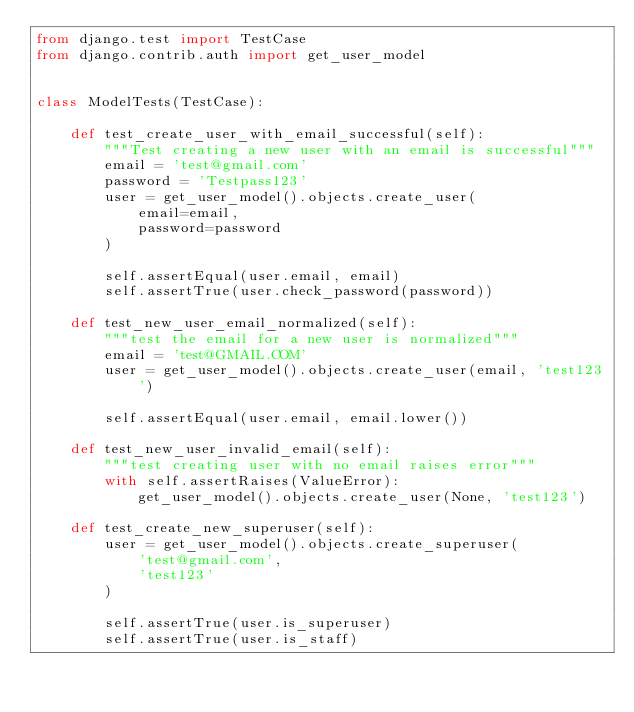Convert code to text. <code><loc_0><loc_0><loc_500><loc_500><_Python_>from django.test import TestCase
from django.contrib.auth import get_user_model


class ModelTests(TestCase):

    def test_create_user_with_email_successful(self):
        """Test creating a new user with an email is successful"""
        email = 'test@gmail.com'
        password = 'Testpass123'
        user = get_user_model().objects.create_user(
            email=email,
            password=password
        )

        self.assertEqual(user.email, email)
        self.assertTrue(user.check_password(password))

    def test_new_user_email_normalized(self):
        """test the email for a new user is normalized"""
        email = 'test@GMAIL.COM'
        user = get_user_model().objects.create_user(email, 'test123')

        self.assertEqual(user.email, email.lower())

    def test_new_user_invalid_email(self):
        """test creating user with no email raises error"""
        with self.assertRaises(ValueError):
            get_user_model().objects.create_user(None, 'test123')

    def test_create_new_superuser(self):
        user = get_user_model().objects.create_superuser(
            'test@gmail.com',
            'test123'
        )

        self.assertTrue(user.is_superuser)
        self.assertTrue(user.is_staff)
</code> 